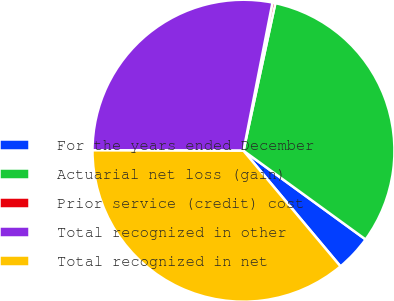Convert chart to OTSL. <chart><loc_0><loc_0><loc_500><loc_500><pie_chart><fcel>For the years ended December<fcel>Actuarial net loss (gain)<fcel>Prior service (credit) cost<fcel>Total recognized in other<fcel>Total recognized in net<nl><fcel>3.89%<fcel>31.61%<fcel>0.31%<fcel>28.03%<fcel>36.15%<nl></chart> 